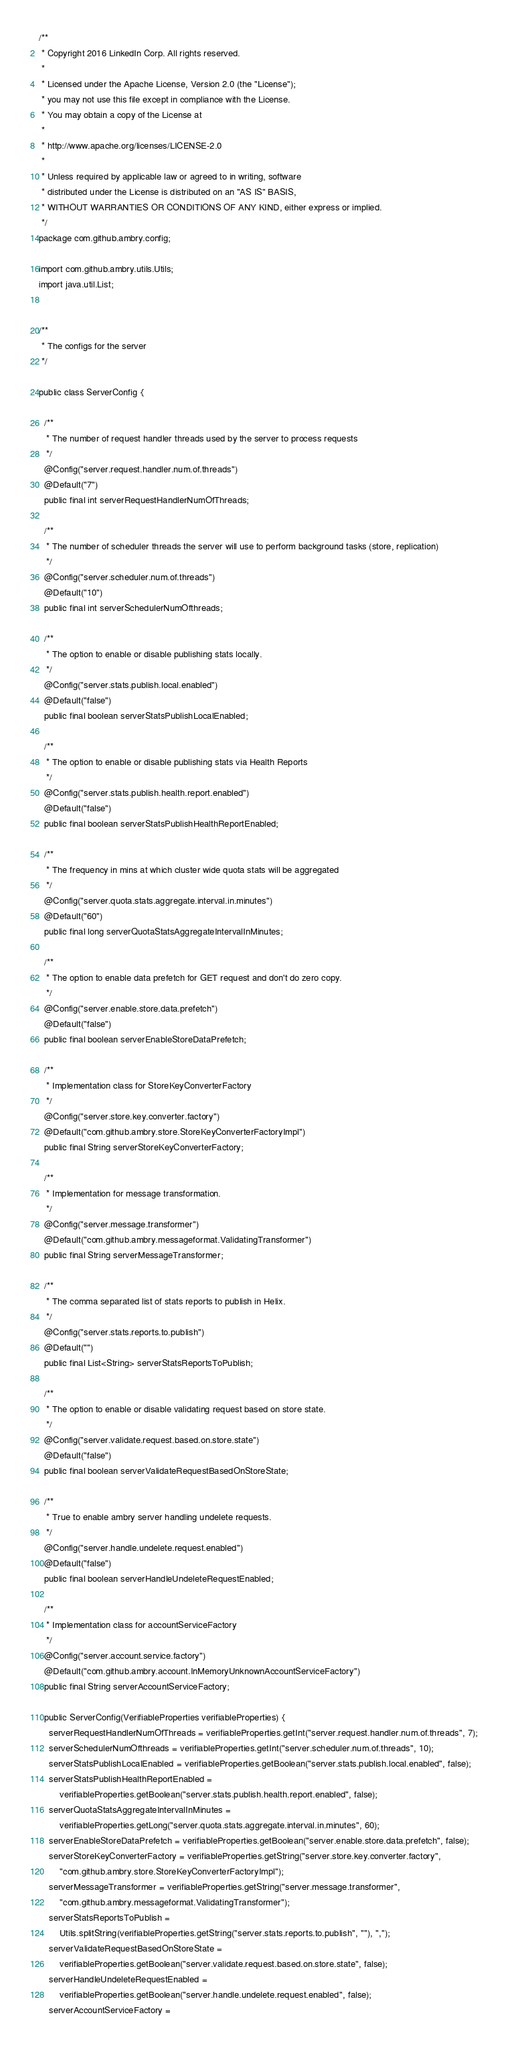Convert code to text. <code><loc_0><loc_0><loc_500><loc_500><_Java_>/**
 * Copyright 2016 LinkedIn Corp. All rights reserved.
 *
 * Licensed under the Apache License, Version 2.0 (the "License");
 * you may not use this file except in compliance with the License.
 * You may obtain a copy of the License at
 *
 * http://www.apache.org/licenses/LICENSE-2.0
 *
 * Unless required by applicable law or agreed to in writing, software
 * distributed under the License is distributed on an "AS IS" BASIS,
 * WITHOUT WARRANTIES OR CONDITIONS OF ANY KIND, either express or implied.
 */
package com.github.ambry.config;

import com.github.ambry.utils.Utils;
import java.util.List;


/**
 * The configs for the server
 */

public class ServerConfig {

  /**
   * The number of request handler threads used by the server to process requests
   */
  @Config("server.request.handler.num.of.threads")
  @Default("7")
  public final int serverRequestHandlerNumOfThreads;

  /**
   * The number of scheduler threads the server will use to perform background tasks (store, replication)
   */
  @Config("server.scheduler.num.of.threads")
  @Default("10")
  public final int serverSchedulerNumOfthreads;

  /**
   * The option to enable or disable publishing stats locally.
   */
  @Config("server.stats.publish.local.enabled")
  @Default("false")
  public final boolean serverStatsPublishLocalEnabled;

  /**
   * The option to enable or disable publishing stats via Health Reports
   */
  @Config("server.stats.publish.health.report.enabled")
  @Default("false")
  public final boolean serverStatsPublishHealthReportEnabled;

  /**
   * The frequency in mins at which cluster wide quota stats will be aggregated
   */
  @Config("server.quota.stats.aggregate.interval.in.minutes")
  @Default("60")
  public final long serverQuotaStatsAggregateIntervalInMinutes;

  /**
   * The option to enable data prefetch for GET request and don't do zero copy.
   */
  @Config("server.enable.store.data.prefetch")
  @Default("false")
  public final boolean serverEnableStoreDataPrefetch;

  /**
   * Implementation class for StoreKeyConverterFactory
   */
  @Config("server.store.key.converter.factory")
  @Default("com.github.ambry.store.StoreKeyConverterFactoryImpl")
  public final String serverStoreKeyConverterFactory;

  /**
   * Implementation for message transformation.
   */
  @Config("server.message.transformer")
  @Default("com.github.ambry.messageformat.ValidatingTransformer")
  public final String serverMessageTransformer;

  /**
   * The comma separated list of stats reports to publish in Helix.
   */
  @Config("server.stats.reports.to.publish")
  @Default("")
  public final List<String> serverStatsReportsToPublish;

  /**
   * The option to enable or disable validating request based on store state.
   */
  @Config("server.validate.request.based.on.store.state")
  @Default("false")
  public final boolean serverValidateRequestBasedOnStoreState;

  /**
   * True to enable ambry server handling undelete requests.
   */
  @Config("server.handle.undelete.request.enabled")
  @Default("false")
  public final boolean serverHandleUndeleteRequestEnabled;

  /**
   * Implementation class for accountServiceFactory
   */
  @Config("server.account.service.factory")
  @Default("com.github.ambry.account.InMemoryUnknownAccountServiceFactory")
  public final String serverAccountServiceFactory;

  public ServerConfig(VerifiableProperties verifiableProperties) {
    serverRequestHandlerNumOfThreads = verifiableProperties.getInt("server.request.handler.num.of.threads", 7);
    serverSchedulerNumOfthreads = verifiableProperties.getInt("server.scheduler.num.of.threads", 10);
    serverStatsPublishLocalEnabled = verifiableProperties.getBoolean("server.stats.publish.local.enabled", false);
    serverStatsPublishHealthReportEnabled =
        verifiableProperties.getBoolean("server.stats.publish.health.report.enabled", false);
    serverQuotaStatsAggregateIntervalInMinutes =
        verifiableProperties.getLong("server.quota.stats.aggregate.interval.in.minutes", 60);
    serverEnableStoreDataPrefetch = verifiableProperties.getBoolean("server.enable.store.data.prefetch", false);
    serverStoreKeyConverterFactory = verifiableProperties.getString("server.store.key.converter.factory",
        "com.github.ambry.store.StoreKeyConverterFactoryImpl");
    serverMessageTransformer = verifiableProperties.getString("server.message.transformer",
        "com.github.ambry.messageformat.ValidatingTransformer");
    serverStatsReportsToPublish =
        Utils.splitString(verifiableProperties.getString("server.stats.reports.to.publish", ""), ",");
    serverValidateRequestBasedOnStoreState =
        verifiableProperties.getBoolean("server.validate.request.based.on.store.state", false);
    serverHandleUndeleteRequestEnabled =
        verifiableProperties.getBoolean("server.handle.undelete.request.enabled", false);
    serverAccountServiceFactory =</code> 